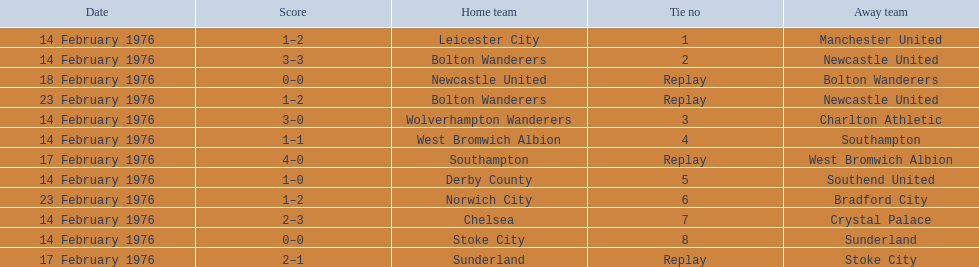Who were all of the teams? Leicester City, Manchester United, Bolton Wanderers, Newcastle United, Newcastle United, Bolton Wanderers, Bolton Wanderers, Newcastle United, Wolverhampton Wanderers, Charlton Athletic, West Bromwich Albion, Southampton, Southampton, West Bromwich Albion, Derby County, Southend United, Norwich City, Bradford City, Chelsea, Crystal Palace, Stoke City, Sunderland, Sunderland, Stoke City. And what were their scores? 1–2, 3–3, 0–0, 1–2, 3–0, 1–1, 4–0, 1–0, 1–2, 2–3, 0–0, 2–1. Between manchester and wolverhampton, who scored more? Wolverhampton Wanderers. 